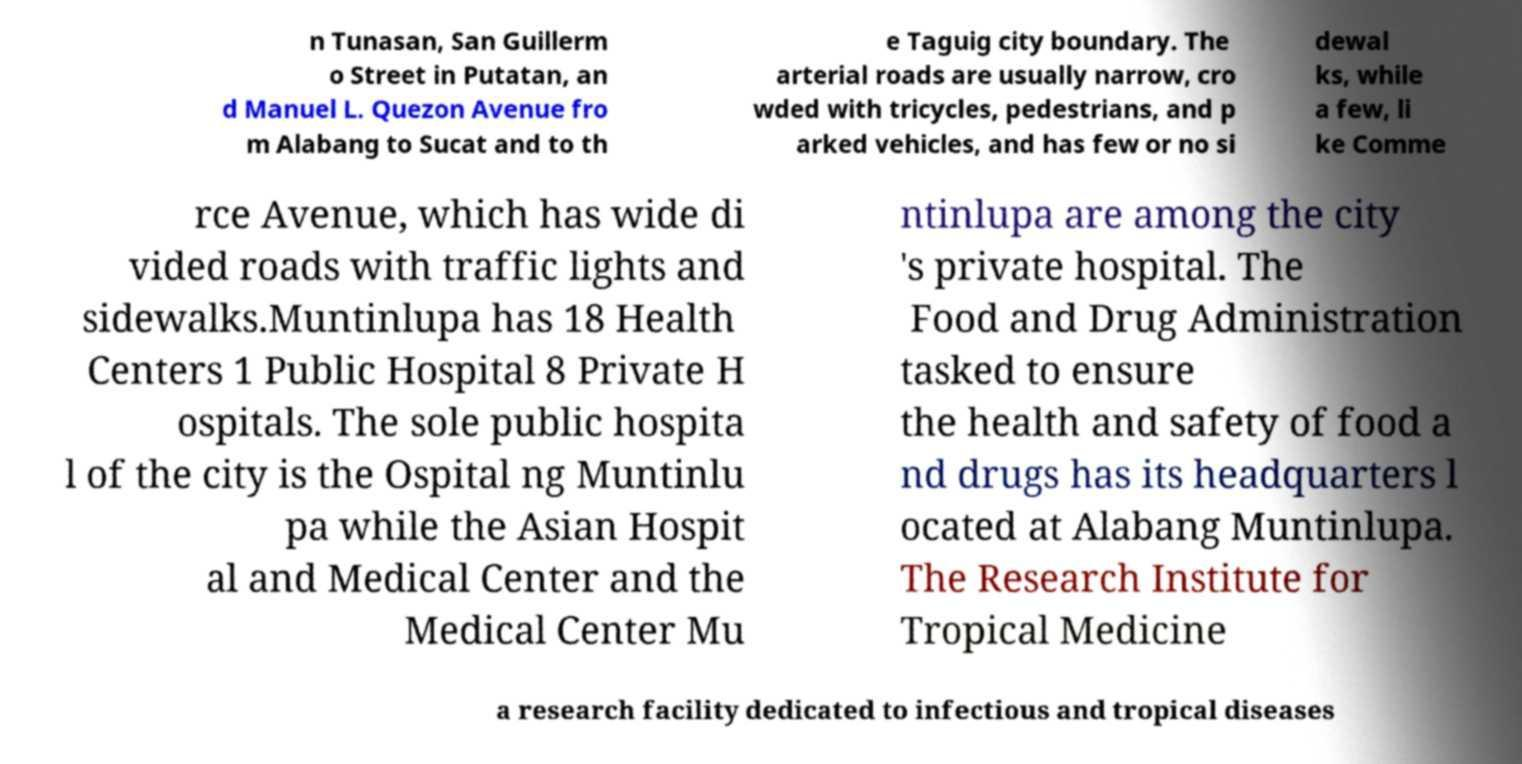I need the written content from this picture converted into text. Can you do that? n Tunasan, San Guillerm o Street in Putatan, an d Manuel L. Quezon Avenue fro m Alabang to Sucat and to th e Taguig city boundary. The arterial roads are usually narrow, cro wded with tricycles, pedestrians, and p arked vehicles, and has few or no si dewal ks, while a few, li ke Comme rce Avenue, which has wide di vided roads with traffic lights and sidewalks.Muntinlupa has 18 Health Centers 1 Public Hospital 8 Private H ospitals. The sole public hospita l of the city is the Ospital ng Muntinlu pa while the Asian Hospit al and Medical Center and the Medical Center Mu ntinlupa are among the city 's private hospital. The Food and Drug Administration tasked to ensure the health and safety of food a nd drugs has its headquarters l ocated at Alabang Muntinlupa. The Research Institute for Tropical Medicine a research facility dedicated to infectious and tropical diseases 